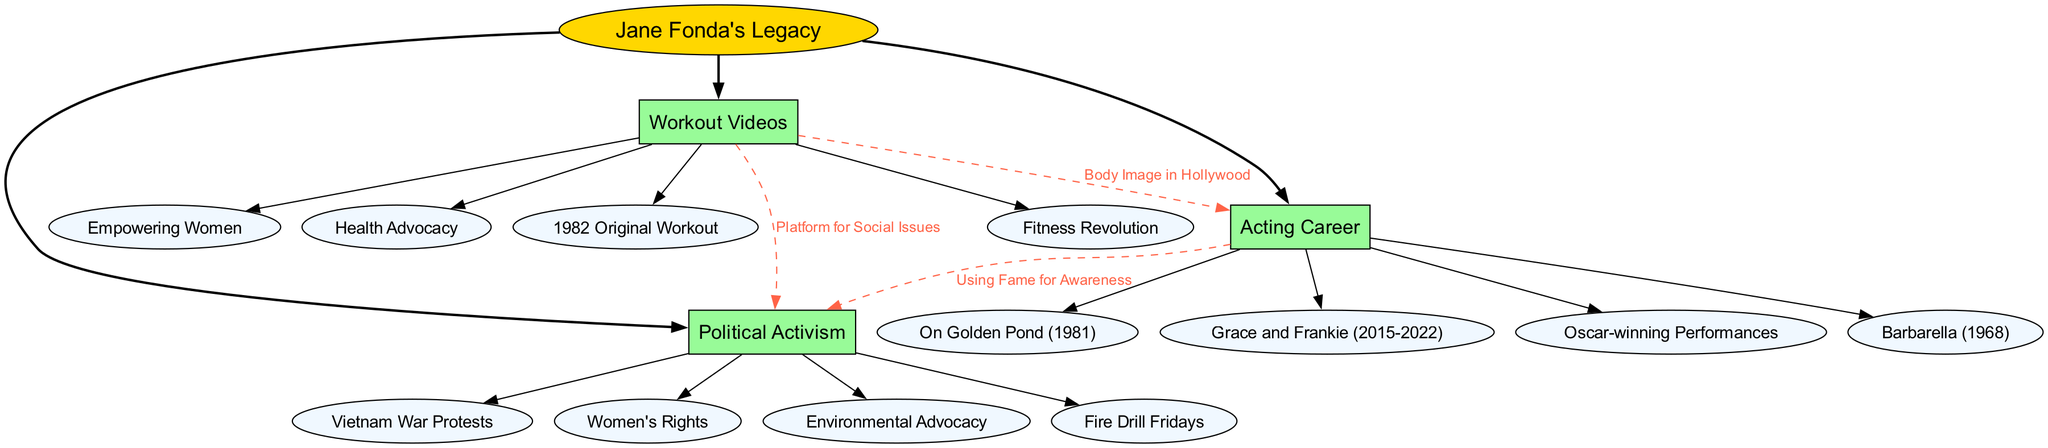What is the central theme of the diagram? The diagram's central theme is labeled as "Jane Fonda's Legacy." This is evident as it is represented by an ellipse at the top of the diagram, which is the main focus from which all other branches stem.
Answer: Jane Fonda's Legacy How many main branches are in the diagram? There are three main branches in the diagram. Each branch is distinctly labeled: "Workout Videos," "Acting Career," and "Political Activism." Counting these, we arrive at a total of three.
Answer: 3 Which sub-branch is associated with "Acting Career"? A sub-branch associated with "Acting Career" is "Grace and Frankie (2015-2022)." This branch can be found directly beneath the "Acting Career" node, indicating it belongs to that category.
Answer: Grace and Frankie (2015-2022) What is the connection between "Workout Videos" and "Political Activism"? The connection labeled "Platform for Social Issues" links "Workout Videos" to "Political Activism." This dashed line indicates that workout videos provided a way to promote social issues, reflecting Jane Fonda's multifaceted approach to activism.
Answer: Platform for Social Issues Which award-winning performances are listed in the "Acting Career" branch? The phrase "Oscar-winning Performances" is explicitly included as a sub-branch in the "Acting Career" section, indicating that it highlights her achievements in award-winning acting roles.
Answer: Oscar-winning Performances How does Fonda's workout relate to her acting career? The relationship is described by the label "Body Image in Hollywood." This shows that her workout videos are connected to her experiences and portrayals as an actress, particularly pertaining to societal standards of body image.
Answer: Body Image in Hollywood What major protest theme is identified in Fonda's activism? "Vietnam War Protests" is indicated as a key theme under the "Political Activism" branch. This highlights her involvement in protests against the Vietnam War, a significant aspect of her activism.
Answer: Vietnam War Protests How many sub-branches are associated with "Workout Videos"? There are four sub-branches linked to "Workout Videos": "1982 Original Workout," "Fitness Revolution," "Empowering Women," and "Health Advocacy." Each of these details a different aspect of her fitness journey.
Answer: 4 What does the connection "Using Fame for Awareness" signify? This connection illustrates how Jane Fonda leveraged her acting fame to bring attention to various political issues, thereby uniting her career with her activism efforts. It shows a strategic use of her visibility for advocacy.
Answer: Using Fame for Awareness 